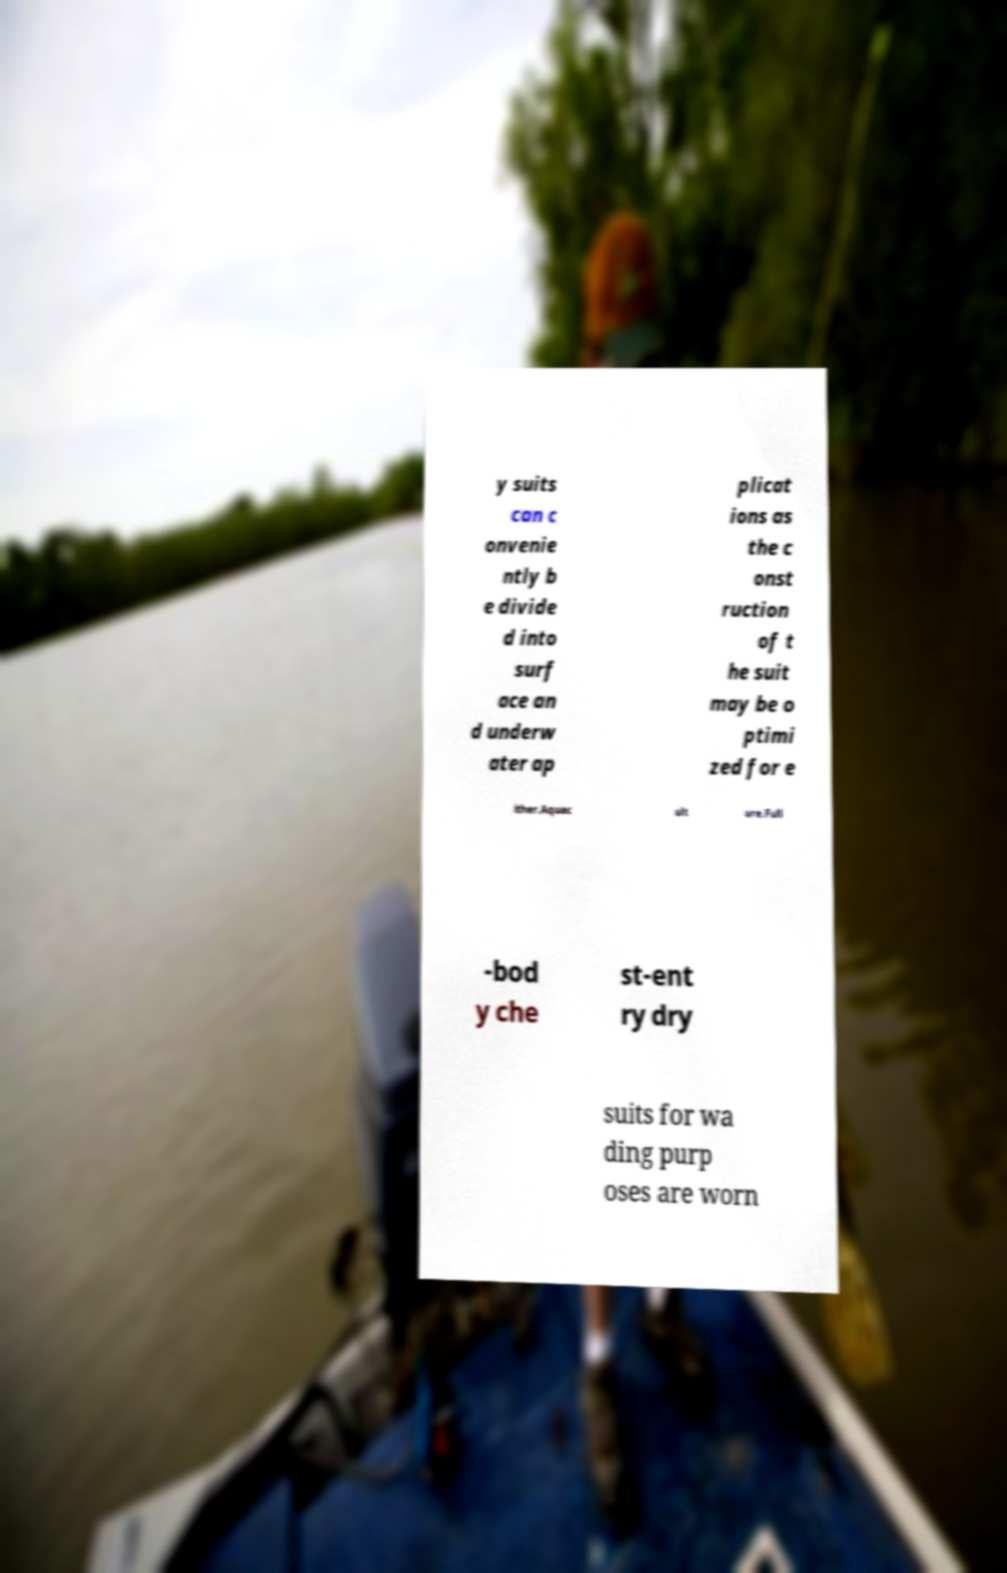Can you accurately transcribe the text from the provided image for me? y suits can c onvenie ntly b e divide d into surf ace an d underw ater ap plicat ions as the c onst ruction of t he suit may be o ptimi zed for e ither.Aquac ult ure.Full -bod y che st-ent ry dry suits for wa ding purp oses are worn 